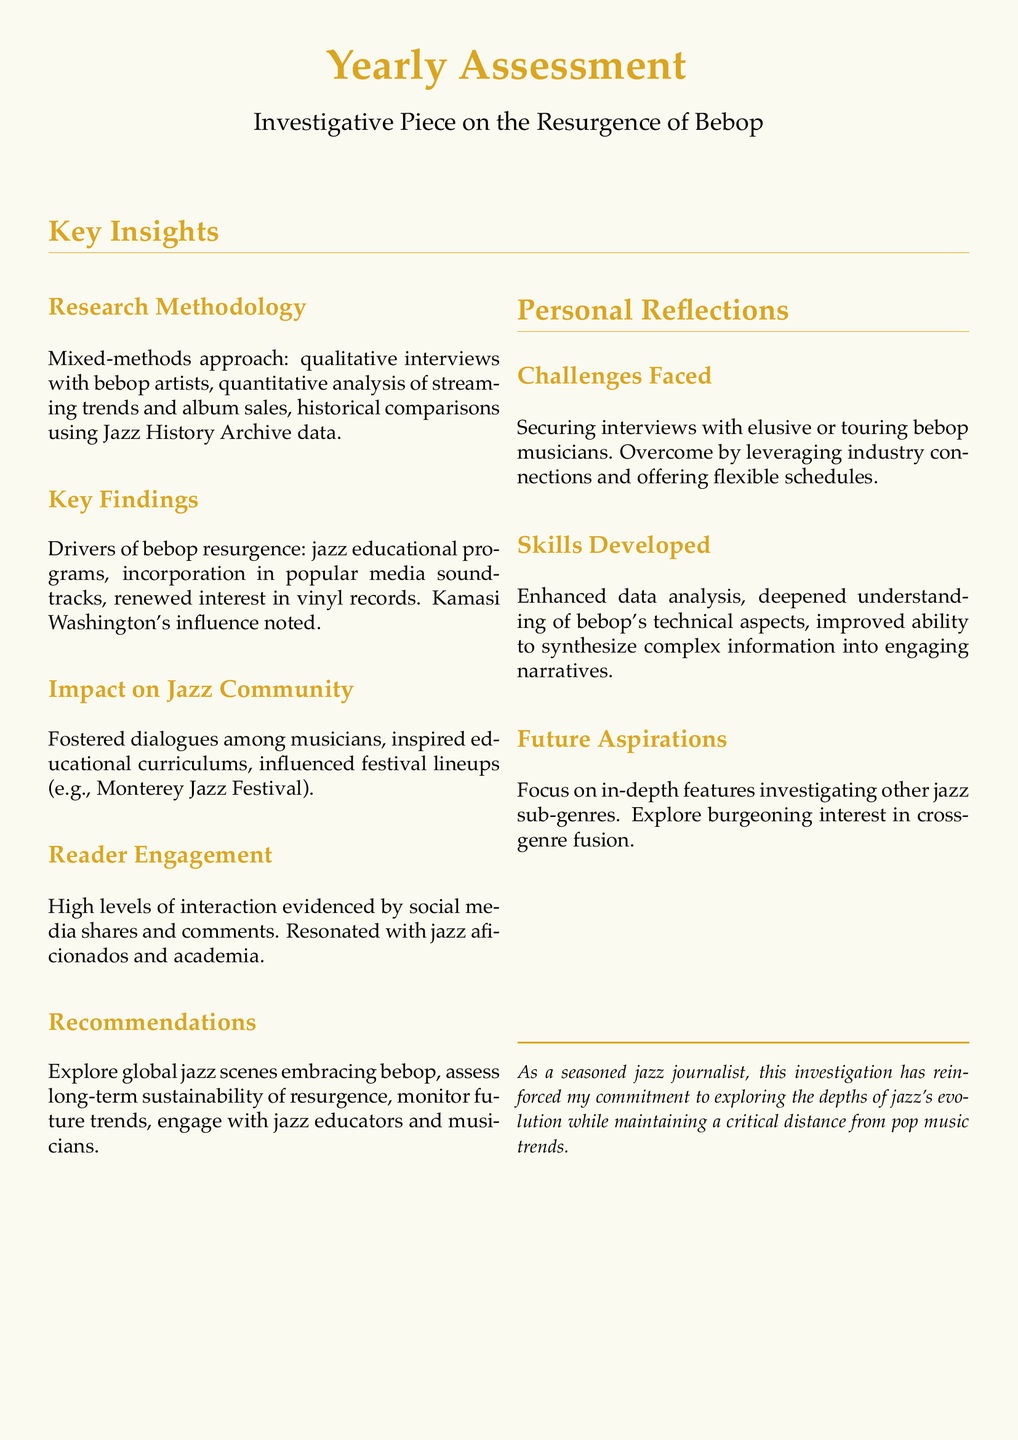What research methodology was used? The document states that a mixed-methods approach was utilized, including various qualitative and quantitative techniques.
Answer: Mixed-methods approach What was a key finding related to the resurgence of bebop? One of the findings was the influence of jazz educational programs on the resurgence of bebop.
Answer: Jazz educational programs Who is noted as an influential figure in the resurgence? The document mentions Kamasi Washington's influence on the resurgence of bebop.
Answer: Kamasi Washington What type of engagement did the piece achieve? The document notes high levels of interaction, particularly on social media, indicating strong reader engagement.
Answer: High levels of interaction What challenges did the journalist face? The document outlines that securing interviews with musicians was a significant challenge faced during the investigation.
Answer: Securing interviews What skills did the journalist enhance during the piece? The journalist developed enhanced data analysis skills as part of the investigative process.
Answer: Enhanced data analysis What future aspirations are mentioned in the document? The document expresses the aspiration to focus on in-depth features investigating other jazz sub-genres.
Answer: In-depth features Which festival's lineup was influenced by the investigation? The document identifies the Monterey Jazz Festival as being influenced by the findings of the investigation.
Answer: Monterey Jazz Festival What is recommended for future studies? The document recommends exploring global jazz scenes that embrace bebop for future investigations.
Answer: Explore global jazz scenes 